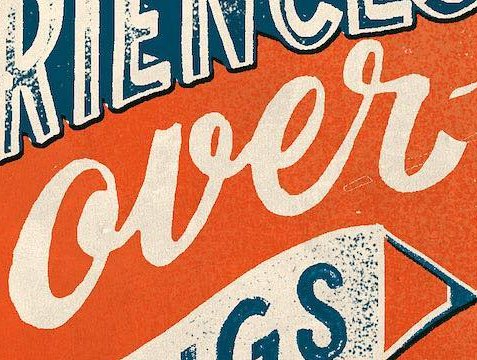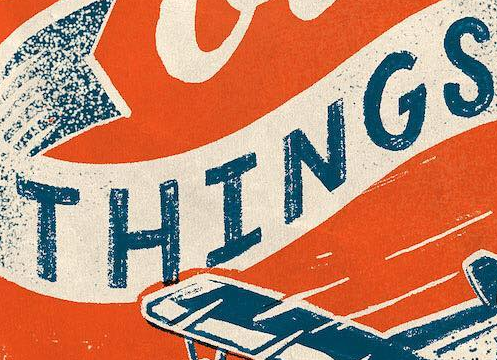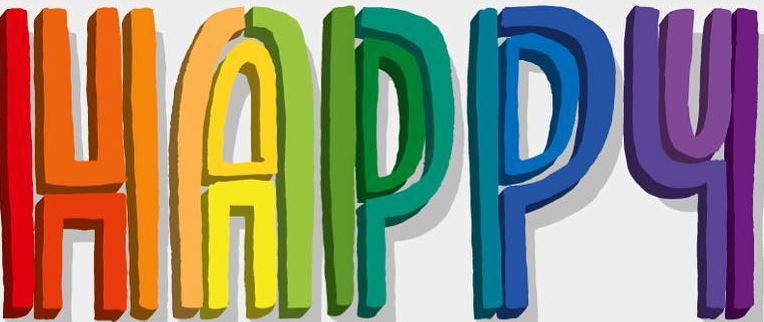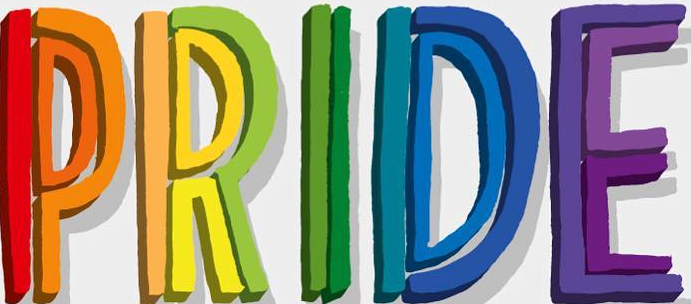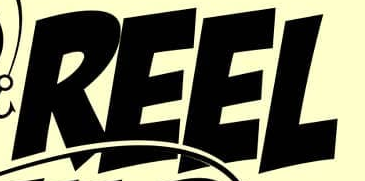What words are shown in these images in order, separated by a semicolon? over; THINGS; HAPPY; PRIDE; REEL 